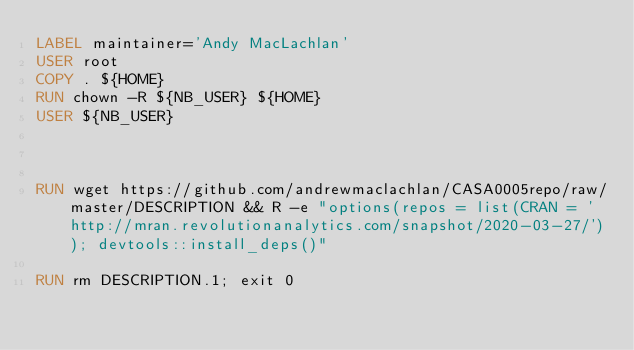<code> <loc_0><loc_0><loc_500><loc_500><_Dockerfile_>LABEL maintainer='Andy MacLachlan'
USER root
COPY . ${HOME}
RUN chown -R ${NB_USER} ${HOME}
USER ${NB_USER}



RUN wget https://github.com/andrewmaclachlan/CASA0005repo/raw/master/DESCRIPTION && R -e "options(repos = list(CRAN = 'http://mran.revolutionanalytics.com/snapshot/2020-03-27/')); devtools::install_deps()"

RUN rm DESCRIPTION.1; exit 0
</code> 